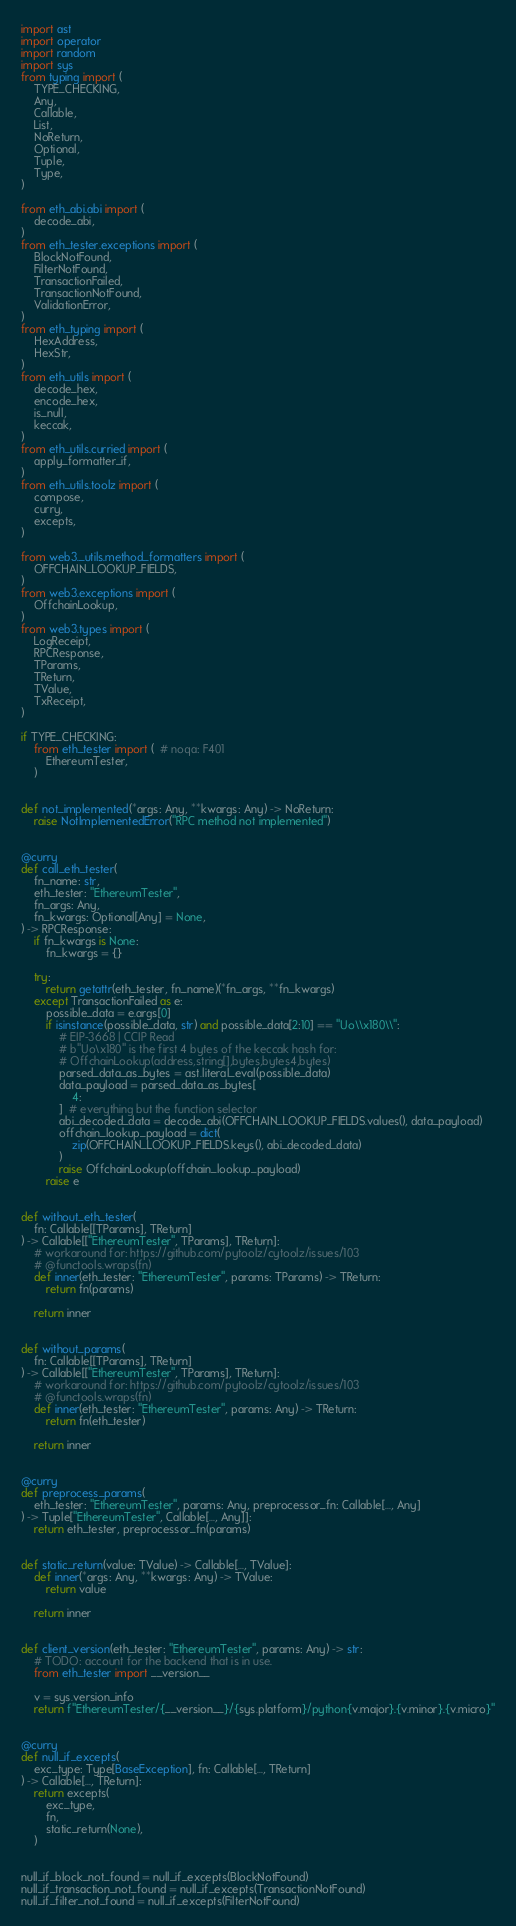<code> <loc_0><loc_0><loc_500><loc_500><_Python_>import ast
import operator
import random
import sys
from typing import (
    TYPE_CHECKING,
    Any,
    Callable,
    List,
    NoReturn,
    Optional,
    Tuple,
    Type,
)

from eth_abi.abi import (
    decode_abi,
)
from eth_tester.exceptions import (
    BlockNotFound,
    FilterNotFound,
    TransactionFailed,
    TransactionNotFound,
    ValidationError,
)
from eth_typing import (
    HexAddress,
    HexStr,
)
from eth_utils import (
    decode_hex,
    encode_hex,
    is_null,
    keccak,
)
from eth_utils.curried import (
    apply_formatter_if,
)
from eth_utils.toolz import (
    compose,
    curry,
    excepts,
)

from web3._utils.method_formatters import (
    OFFCHAIN_LOOKUP_FIELDS,
)
from web3.exceptions import (
    OffchainLookup,
)
from web3.types import (
    LogReceipt,
    RPCResponse,
    TParams,
    TReturn,
    TValue,
    TxReceipt,
)

if TYPE_CHECKING:
    from eth_tester import (  # noqa: F401
        EthereumTester,
    )


def not_implemented(*args: Any, **kwargs: Any) -> NoReturn:
    raise NotImplementedError("RPC method not implemented")


@curry
def call_eth_tester(
    fn_name: str,
    eth_tester: "EthereumTester",
    fn_args: Any,
    fn_kwargs: Optional[Any] = None,
) -> RPCResponse:
    if fn_kwargs is None:
        fn_kwargs = {}

    try:
        return getattr(eth_tester, fn_name)(*fn_args, **fn_kwargs)
    except TransactionFailed as e:
        possible_data = e.args[0]
        if isinstance(possible_data, str) and possible_data[2:10] == "Uo\\x180\\":
            # EIP-3668 | CCIP Read
            # b"Uo\x180" is the first 4 bytes of the keccak hash for:
            # OffchainLookup(address,string[],bytes,bytes4,bytes)
            parsed_data_as_bytes = ast.literal_eval(possible_data)
            data_payload = parsed_data_as_bytes[
                4:
            ]  # everything but the function selector
            abi_decoded_data = decode_abi(OFFCHAIN_LOOKUP_FIELDS.values(), data_payload)
            offchain_lookup_payload = dict(
                zip(OFFCHAIN_LOOKUP_FIELDS.keys(), abi_decoded_data)
            )
            raise OffchainLookup(offchain_lookup_payload)
        raise e


def without_eth_tester(
    fn: Callable[[TParams], TReturn]
) -> Callable[["EthereumTester", TParams], TReturn]:
    # workaround for: https://github.com/pytoolz/cytoolz/issues/103
    # @functools.wraps(fn)
    def inner(eth_tester: "EthereumTester", params: TParams) -> TReturn:
        return fn(params)

    return inner


def without_params(
    fn: Callable[[TParams], TReturn]
) -> Callable[["EthereumTester", TParams], TReturn]:
    # workaround for: https://github.com/pytoolz/cytoolz/issues/103
    # @functools.wraps(fn)
    def inner(eth_tester: "EthereumTester", params: Any) -> TReturn:
        return fn(eth_tester)

    return inner


@curry
def preprocess_params(
    eth_tester: "EthereumTester", params: Any, preprocessor_fn: Callable[..., Any]
) -> Tuple["EthereumTester", Callable[..., Any]]:
    return eth_tester, preprocessor_fn(params)


def static_return(value: TValue) -> Callable[..., TValue]:
    def inner(*args: Any, **kwargs: Any) -> TValue:
        return value

    return inner


def client_version(eth_tester: "EthereumTester", params: Any) -> str:
    # TODO: account for the backend that is in use.
    from eth_tester import __version__

    v = sys.version_info
    return f"EthereumTester/{__version__}/{sys.platform}/python{v.major}.{v.minor}.{v.micro}"


@curry
def null_if_excepts(
    exc_type: Type[BaseException], fn: Callable[..., TReturn]
) -> Callable[..., TReturn]:
    return excepts(
        exc_type,
        fn,
        static_return(None),
    )


null_if_block_not_found = null_if_excepts(BlockNotFound)
null_if_transaction_not_found = null_if_excepts(TransactionNotFound)
null_if_filter_not_found = null_if_excepts(FilterNotFound)</code> 